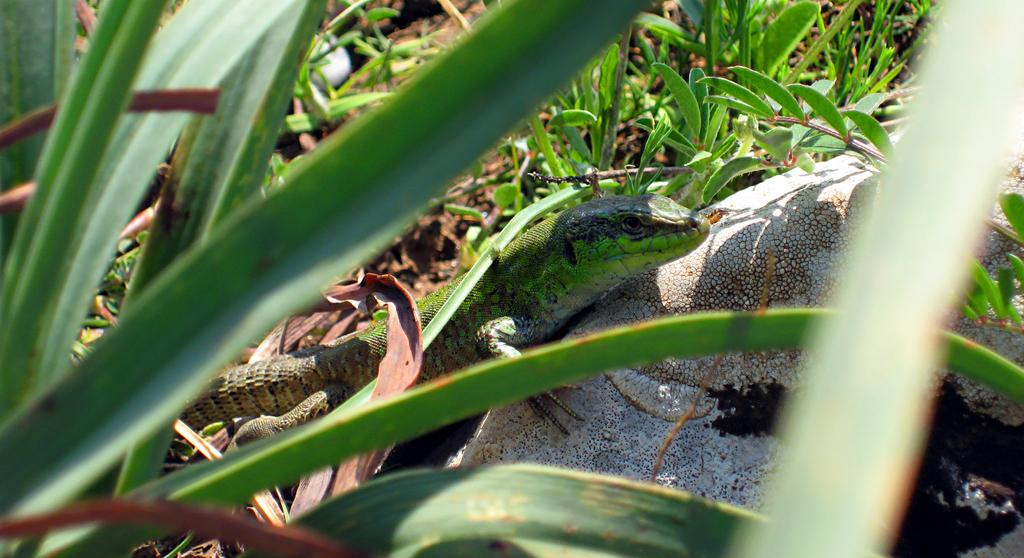What type of animal is in the center of the image? There is a reptile in the center of the image. What other object can be seen on the right side of the image? There is a rock on the right side of the image. What type of vegetation is visible in the image? There is grass visible in the image. What type of addition problem can be solved using the numbers on the reptile's scales in the image? There are no numbers or addition problems present on the reptile's scales in the image. 